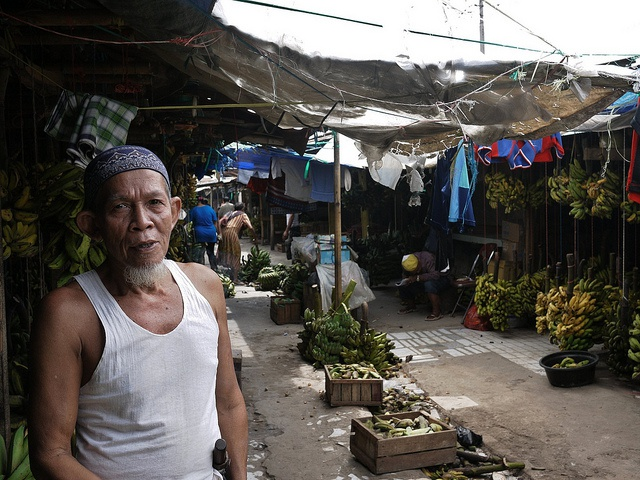Describe the objects in this image and their specific colors. I can see people in black, darkgray, gray, and lightgray tones, banana in black, darkgreen, and olive tones, banana in black and olive tones, banana in black and olive tones, and people in black, olive, and gray tones in this image. 